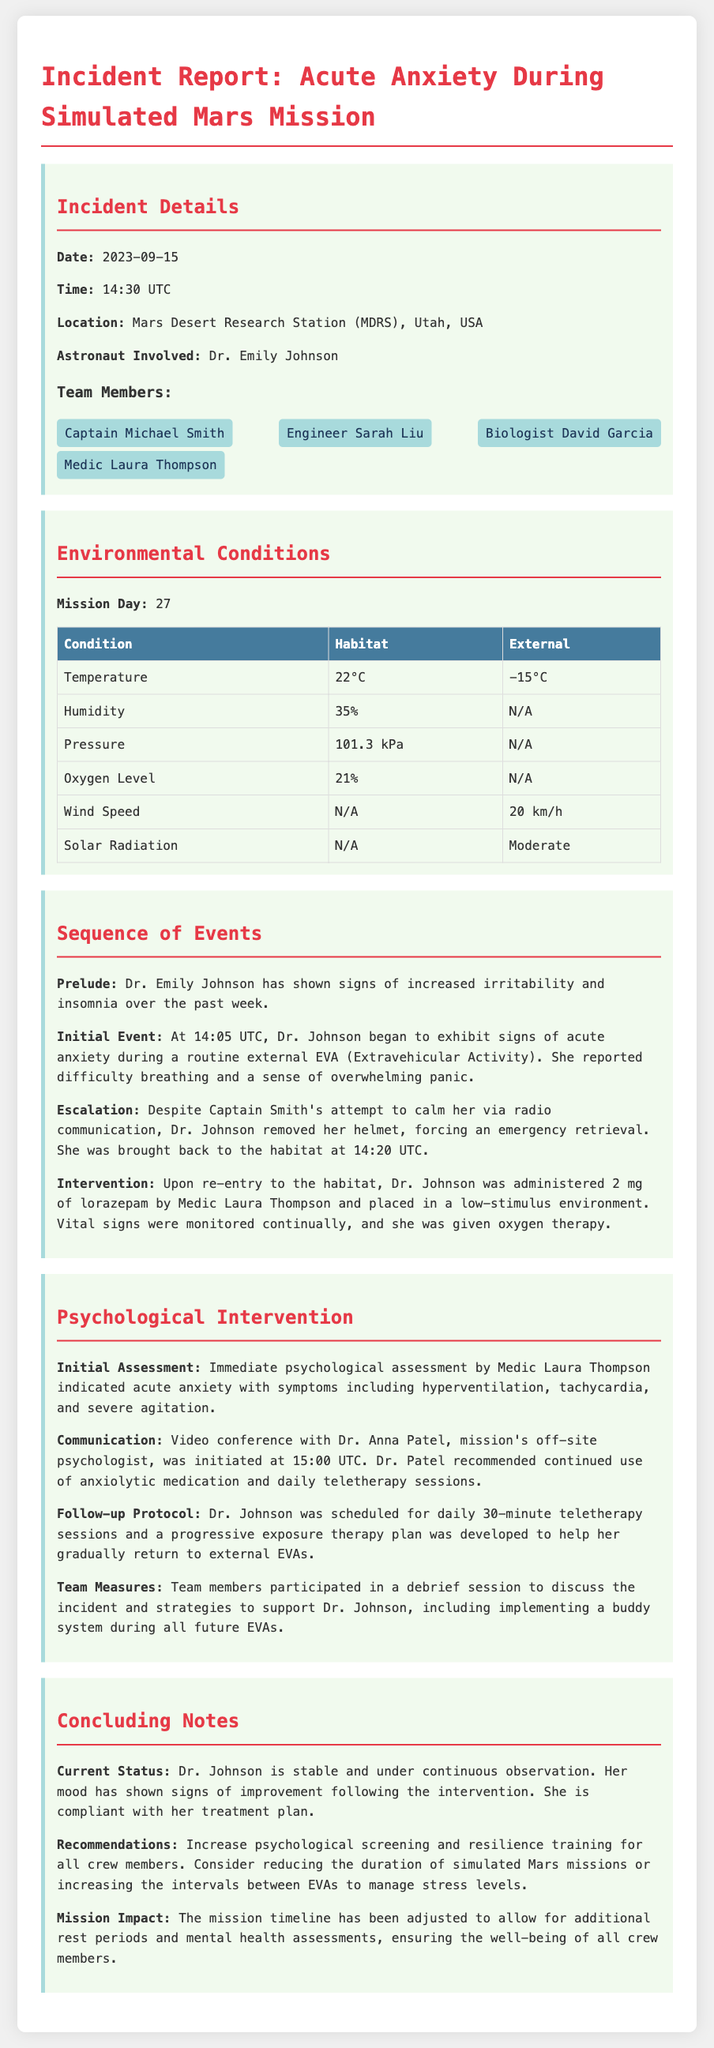what was the date of the incident? The incident occurred on September 15, 2023, as stated in the incident details section.
Answer: September 15, 2023 who was the astronaut involved in the incident? The incident report identifies Dr. Emily Johnson as the astronaut involved.
Answer: Dr. Emily Johnson what was the temperature inside the habitat during the incident? The document specifies that the habitat temperature was 22°C at the time of the incident.
Answer: 22°C what intervention was administered to Dr. Johnson upon re-entry? The document states that Dr. Johnson was administered 2 mg of lorazepam.
Answer: 2 mg of lorazepam what psychological assessment was conducted immediately after the incident? The psychological assessment indicated acute anxiety with symptoms such as hyperventilation, tachycardia, and severe agitation.
Answer: acute anxiety what type of therapy was recommended for Dr. Johnson? The off-site psychologist recommended continued use of anxiolytic medication and daily teletherapy sessions.
Answer: daily teletherapy sessions how many teletherapy sessions were scheduled for Dr. Johnson following the incident? The report mentions that Dr. Johnson was scheduled for daily 30-minute teletherapy sessions.
Answer: daily 30-minute sessions what recommendation was made regarding psychological screening for crew members? The document recommends increasing psychological screening and resilience training for all crew members.
Answer: increase psychological screening 